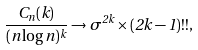<formula> <loc_0><loc_0><loc_500><loc_500>\frac { C _ { n } ( k ) } { ( n \log n ) ^ { k } } \rightarrow \sigma ^ { 2 k } \times ( 2 k - 1 ) ! ! ,</formula> 